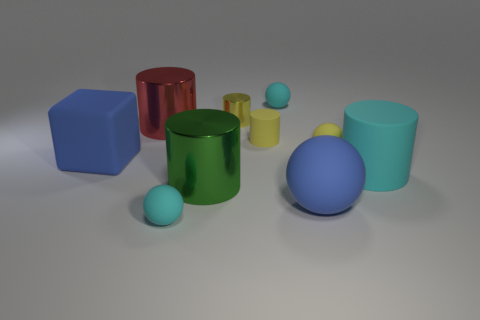Subtract all yellow cylinders. How many were subtracted if there are1yellow cylinders left? 1 Subtract 1 balls. How many balls are left? 3 Subtract all green metal cylinders. How many cylinders are left? 4 Subtract all cyan cylinders. How many cylinders are left? 4 Subtract all brown cylinders. Subtract all purple balls. How many cylinders are left? 5 Subtract all balls. How many objects are left? 6 Subtract 0 blue cylinders. How many objects are left? 10 Subtract all cyan rubber spheres. Subtract all red objects. How many objects are left? 7 Add 1 tiny yellow metal cylinders. How many tiny yellow metal cylinders are left? 2 Add 4 blocks. How many blocks exist? 5 